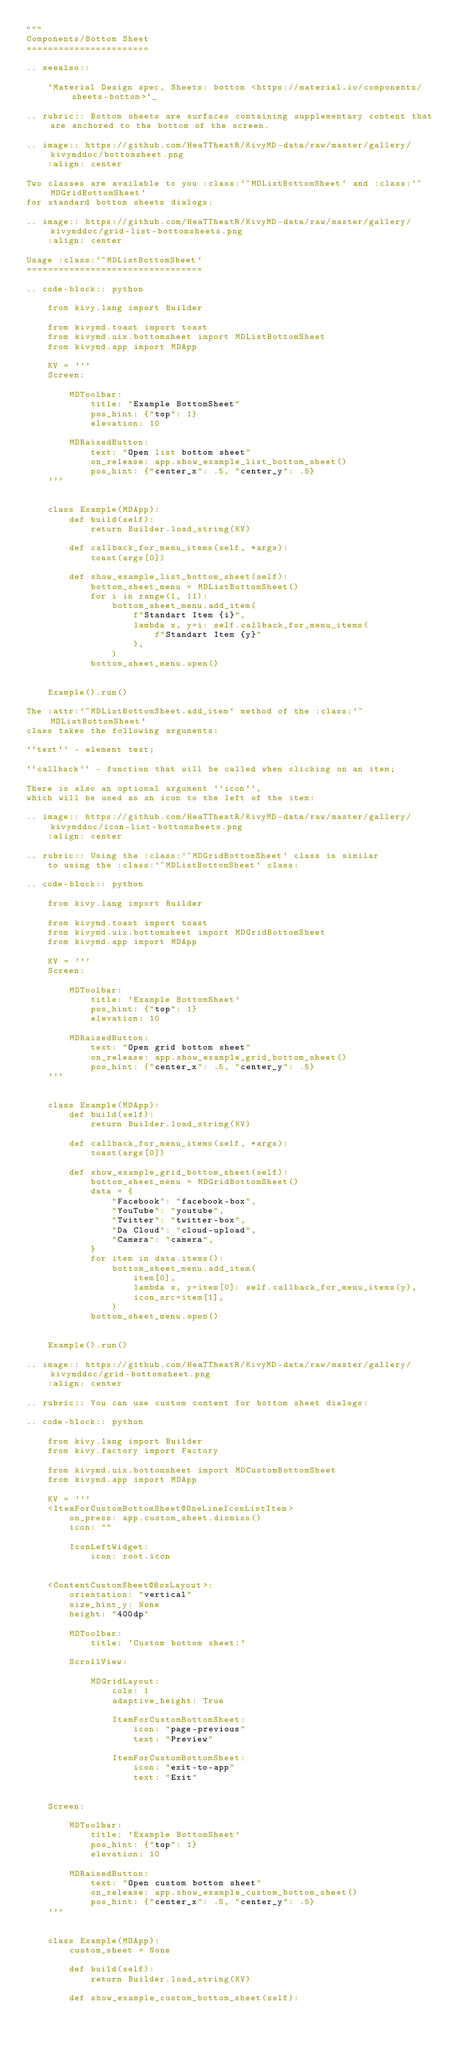Convert code to text. <code><loc_0><loc_0><loc_500><loc_500><_Python_>"""
Components/Bottom Sheet
=======================

.. seealso::

    `Material Design spec, Sheets: bottom <https://material.io/components/sheets-bottom>`_

.. rubric:: Bottom sheets are surfaces containing supplementary content that are anchored to the bottom of the screen.

.. image:: https://github.com/HeaTTheatR/KivyMD-data/raw/master/gallery/kivymddoc/bottomsheet.png
    :align: center

Two classes are available to you :class:`~MDListBottomSheet` and :class:`~MDGridBottomSheet`
for standard bottom sheets dialogs:

.. image:: https://github.com/HeaTTheatR/KivyMD-data/raw/master/gallery/kivymddoc/grid-list-bottomsheets.png
    :align: center

Usage :class:`~MDListBottomSheet`
=================================

.. code-block:: python

    from kivy.lang import Builder

    from kivymd.toast import toast
    from kivymd.uix.bottomsheet import MDListBottomSheet
    from kivymd.app import MDApp

    KV = '''
    Screen:

        MDToolbar:
            title: "Example BottomSheet"
            pos_hint: {"top": 1}
            elevation: 10

        MDRaisedButton:
            text: "Open list bottom sheet"
            on_release: app.show_example_list_bottom_sheet()
            pos_hint: {"center_x": .5, "center_y": .5}
    '''


    class Example(MDApp):
        def build(self):
            return Builder.load_string(KV)

        def callback_for_menu_items(self, *args):
            toast(args[0])

        def show_example_list_bottom_sheet(self):
            bottom_sheet_menu = MDListBottomSheet()
            for i in range(1, 11):
                bottom_sheet_menu.add_item(
                    f"Standart Item {i}",
                    lambda x, y=i: self.callback_for_menu_items(
                        f"Standart Item {y}"
                    ),
                )
            bottom_sheet_menu.open()


    Example().run()

The :attr:`~MDListBottomSheet.add_item` method of the :class:`~MDListBottomSheet`
class takes the following arguments:

``text`` - element text;

``callback`` - function that will be called when clicking on an item;

There is also an optional argument ``icon``,
which will be used as an icon to the left of the item:

.. image:: https://github.com/HeaTTheatR/KivyMD-data/raw/master/gallery/kivymddoc/icon-list-bottomsheets.png
    :align: center

.. rubric:: Using the :class:`~MDGridBottomSheet` class is similar
    to using the :class:`~MDListBottomSheet` class:

.. code-block:: python

    from kivy.lang import Builder

    from kivymd.toast import toast
    from kivymd.uix.bottomsheet import MDGridBottomSheet
    from kivymd.app import MDApp

    KV = '''
    Screen:

        MDToolbar:
            title: 'Example BottomSheet'
            pos_hint: {"top": 1}
            elevation: 10

        MDRaisedButton:
            text: "Open grid bottom sheet"
            on_release: app.show_example_grid_bottom_sheet()
            pos_hint: {"center_x": .5, "center_y": .5}
    '''


    class Example(MDApp):
        def build(self):
            return Builder.load_string(KV)

        def callback_for_menu_items(self, *args):
            toast(args[0])

        def show_example_grid_bottom_sheet(self):
            bottom_sheet_menu = MDGridBottomSheet()
            data = {
                "Facebook": "facebook-box",
                "YouTube": "youtube",
                "Twitter": "twitter-box",
                "Da Cloud": "cloud-upload",
                "Camera": "camera",
            }
            for item in data.items():
                bottom_sheet_menu.add_item(
                    item[0],
                    lambda x, y=item[0]: self.callback_for_menu_items(y),
                    icon_src=item[1],
                )
            bottom_sheet_menu.open()


    Example().run()

.. image:: https://github.com/HeaTTheatR/KivyMD-data/raw/master/gallery/kivymddoc/grid-bottomsheet.png
    :align: center

.. rubric:: You can use custom content for bottom sheet dialogs:

.. code-block:: python

    from kivy.lang import Builder
    from kivy.factory import Factory

    from kivymd.uix.bottomsheet import MDCustomBottomSheet
    from kivymd.app import MDApp

    KV = '''
    <ItemForCustomBottomSheet@OneLineIconListItem>
        on_press: app.custom_sheet.dismiss()
        icon: ""

        IconLeftWidget:
            icon: root.icon


    <ContentCustomSheet@BoxLayout>:
        orientation: "vertical"
        size_hint_y: None
        height: "400dp"

        MDToolbar:
            title: 'Custom bottom sheet:'

        ScrollView:

            MDGridLayout:
                cols: 1
                adaptive_height: True

                ItemForCustomBottomSheet:
                    icon: "page-previous"
                    text: "Preview"

                ItemForCustomBottomSheet:
                    icon: "exit-to-app"
                    text: "Exit"


    Screen:

        MDToolbar:
            title: 'Example BottomSheet'
            pos_hint: {"top": 1}
            elevation: 10

        MDRaisedButton:
            text: "Open custom bottom sheet"
            on_release: app.show_example_custom_bottom_sheet()
            pos_hint: {"center_x": .5, "center_y": .5}
    '''


    class Example(MDApp):
        custom_sheet = None

        def build(self):
            return Builder.load_string(KV)

        def show_example_custom_bottom_sheet(self):</code> 